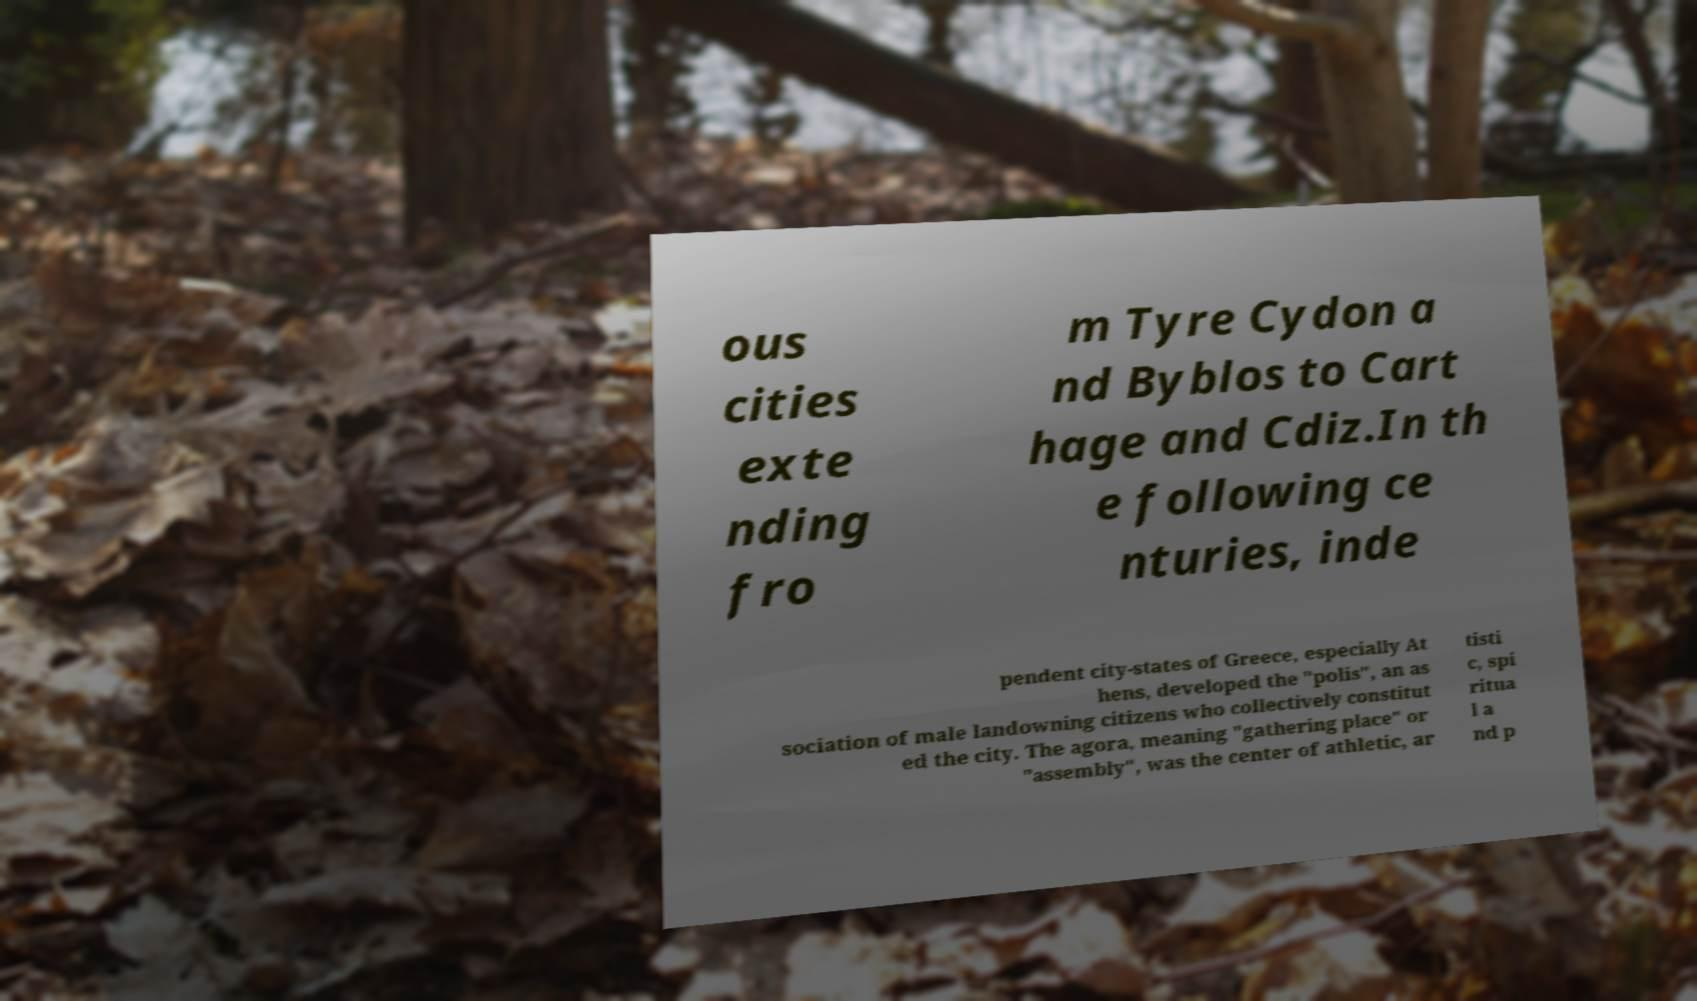Please identify and transcribe the text found in this image. ous cities exte nding fro m Tyre Cydon a nd Byblos to Cart hage and Cdiz.In th e following ce nturies, inde pendent city-states of Greece, especially At hens, developed the "polis", an as sociation of male landowning citizens who collectively constitut ed the city. The agora, meaning "gathering place" or "assembly", was the center of athletic, ar tisti c, spi ritua l a nd p 